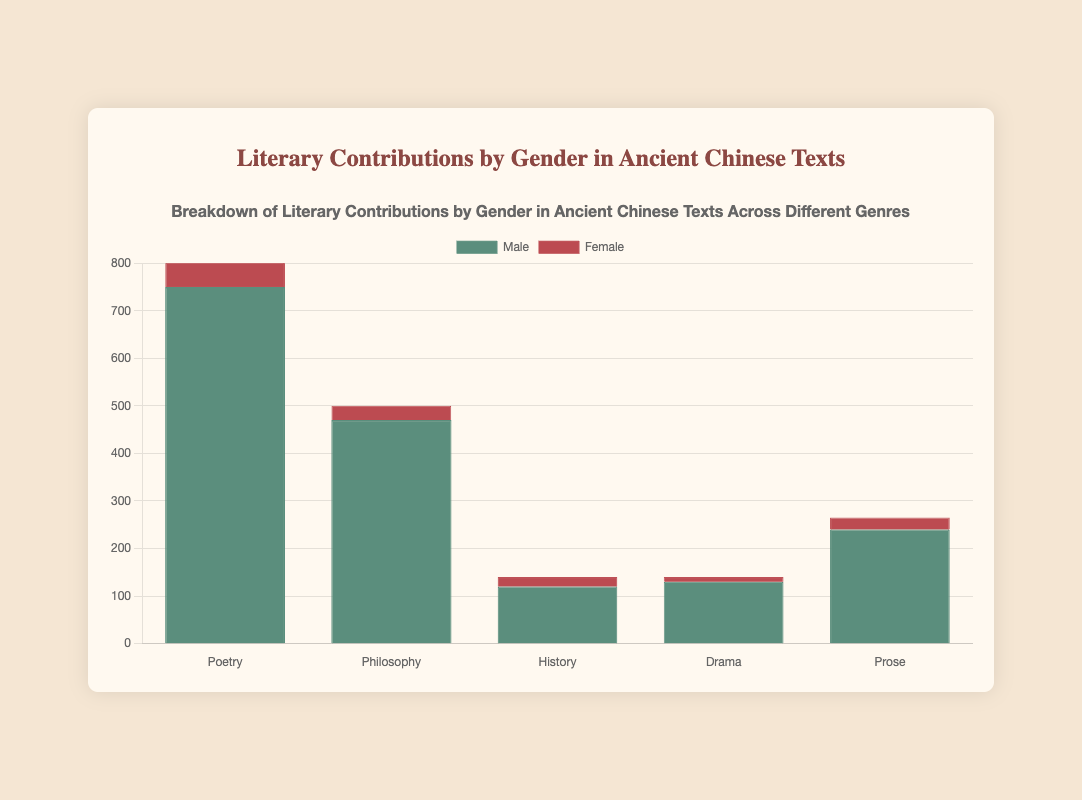Which genre has the highest total literary contributions by males? Looking at the heights of the bars for each genre, the bar for Poetry under Male is the tallest. This indicates that Poetry has the highest total literary contributions by males.
Answer: Poetry What is the total literary contribution count for females in the Philosophy genre? The data in the figure shows that Ban Zhao is the only female contributor in the Philosophy genre with a count of 30. Thus, the total contribution count for females in Philosophy is 30.
Answer: 30 How do the literary contributions by females in the Drama genre compare to those in the Prose genre? Comparing the heights of the red bars for Drama and Prose, the figure shows that the Drama genre's female contributions total 10 (Li Qingzhao), whereas the Prose genre's female contributions total 25 (Ban Zhao). Therefore, the female contributions in Drama are less than those in Prose.
Answer: Less in Drama What is the difference in total contributions between males and females in the History genre? In the History genre, male contributions are 50 (Sima Qian) + 40 (Ban Gu) + 30 (Zuo Qiuming) = 120, and female contributions are 20 (Ban Zhao). The difference is 120 - 20 = 100.
Answer: 100 Which genre shows the smallest disparity between male and female contributions? By comparing the bar heights, the History genre shows the smallest disparity as the male bar (120) and female bar (20) are closer compared to other genres.
Answer: History What is the combined total contributions of females across all genres? Adding up the female contributions: Poetry = 50 (Xue Tao) + 80 (Li Qingzhao) = 130, Philosophy = 30 (Ban Zhao), History = 20 (Ban Zhao), Drama = 10 (Li Qingzhao), Prose = 25 (Ban Zhao). The combined total is 130 + 30 + 20 + 10 + 25 = 215.
Answer: 215 If an additional female author contributed 20 entries to the Poetry genre, how would the total female contribution to Poetry compare to the male contribution in that genre? The current female contribution in Poetry is 50 (Xue Tao) + 80 (Li Qingzhao) = 130. Adding 20 would make it 150. The male contribution is 300 (Li Bai) + 200 (Wang Wei) + 250 (Du Fu) = 750. Therefore, 150 is still less than 750, but the gap would be smaller.
Answer: Still less, but smaller Which genre has the most balanced contributions between male and female authors? By inspecting the proportional heights of the bars for each genre, the Prose genre shows more balance as the difference between male (100 + 80 + 60 = 240) and female (25) contributions is proportionately smaller compared to other genres.
Answer: Prose 